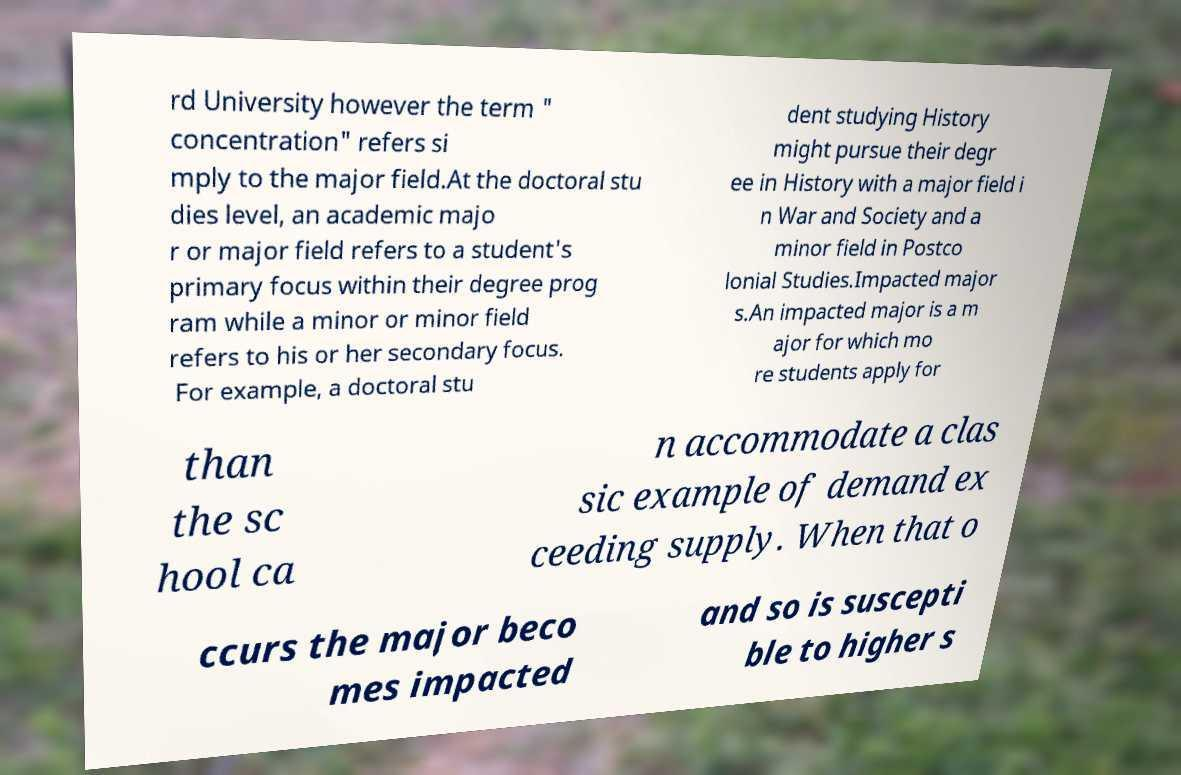I need the written content from this picture converted into text. Can you do that? rd University however the term " concentration" refers si mply to the major field.At the doctoral stu dies level, an academic majo r or major field refers to a student's primary focus within their degree prog ram while a minor or minor field refers to his or her secondary focus. For example, a doctoral stu dent studying History might pursue their degr ee in History with a major field i n War and Society and a minor field in Postco lonial Studies.Impacted major s.An impacted major is a m ajor for which mo re students apply for than the sc hool ca n accommodate a clas sic example of demand ex ceeding supply. When that o ccurs the major beco mes impacted and so is suscepti ble to higher s 